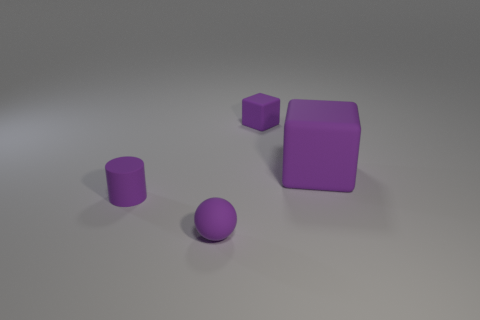Add 4 large matte cubes. How many objects exist? 8 Subtract 1 cylinders. How many cylinders are left? 0 Subtract all spheres. How many objects are left? 3 Subtract all large matte blocks. Subtract all rubber blocks. How many objects are left? 1 Add 4 purple objects. How many purple objects are left? 8 Add 3 tiny objects. How many tiny objects exist? 6 Subtract 0 cyan cubes. How many objects are left? 4 Subtract all brown spheres. Subtract all green blocks. How many spheres are left? 1 